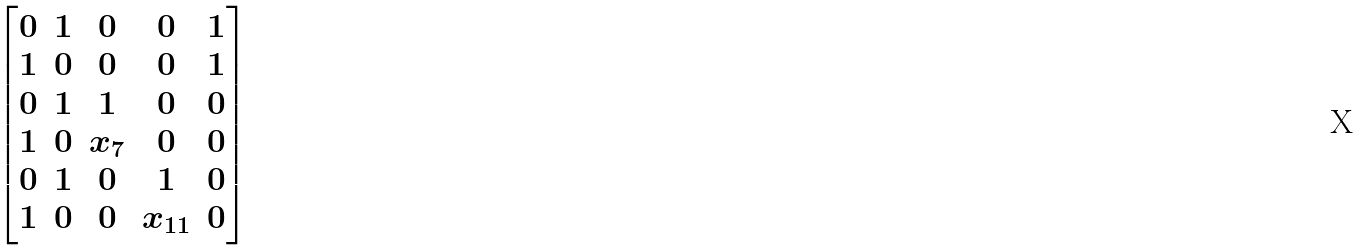Convert formula to latex. <formula><loc_0><loc_0><loc_500><loc_500>\begin{bmatrix} 0 & 1 & 0 & 0 & 1 \\ 1 & 0 & 0 & 0 & 1 \\ 0 & 1 & 1 & 0 & 0 \\ 1 & 0 & x _ { 7 } & 0 & 0 \\ 0 & 1 & 0 & 1 & 0 \\ 1 & 0 & 0 & x _ { 1 1 } & 0 \end{bmatrix}</formula> 